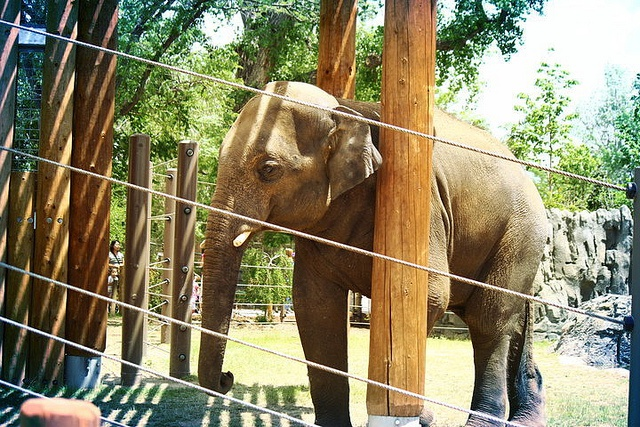Describe the objects in this image and their specific colors. I can see elephant in black, maroon, and beige tones, people in black, ivory, olive, and tan tones, and people in black, maroon, darkgray, and ivory tones in this image. 